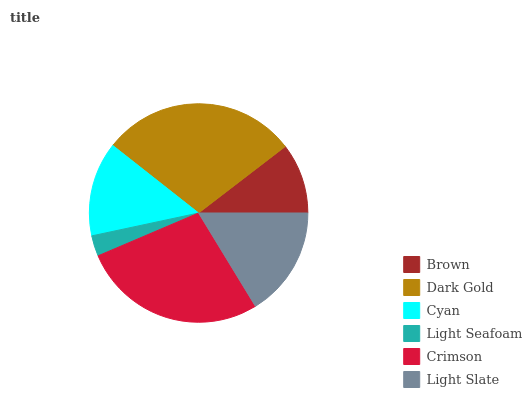Is Light Seafoam the minimum?
Answer yes or no. Yes. Is Dark Gold the maximum?
Answer yes or no. Yes. Is Cyan the minimum?
Answer yes or no. No. Is Cyan the maximum?
Answer yes or no. No. Is Dark Gold greater than Cyan?
Answer yes or no. Yes. Is Cyan less than Dark Gold?
Answer yes or no. Yes. Is Cyan greater than Dark Gold?
Answer yes or no. No. Is Dark Gold less than Cyan?
Answer yes or no. No. Is Light Slate the high median?
Answer yes or no. Yes. Is Cyan the low median?
Answer yes or no. Yes. Is Brown the high median?
Answer yes or no. No. Is Brown the low median?
Answer yes or no. No. 